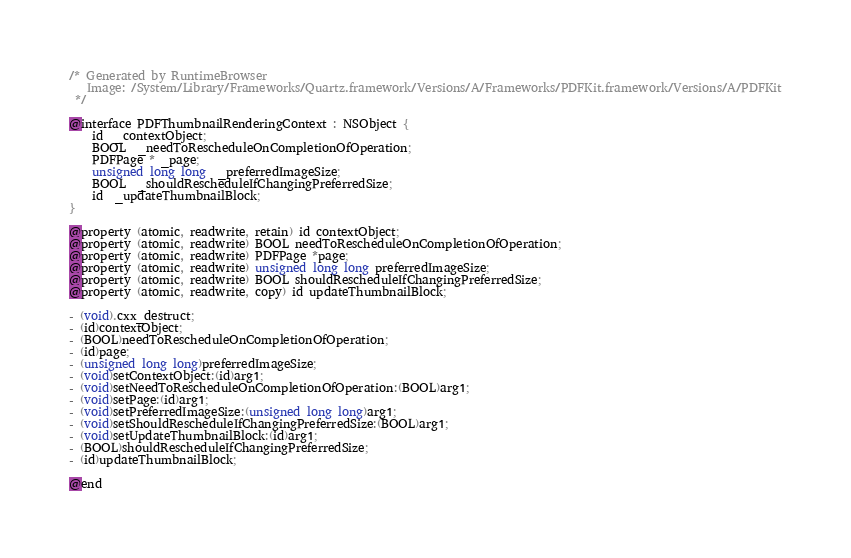Convert code to text. <code><loc_0><loc_0><loc_500><loc_500><_C_>/* Generated by RuntimeBrowser
   Image: /System/Library/Frameworks/Quartz.framework/Versions/A/Frameworks/PDFKit.framework/Versions/A/PDFKit
 */

@interface PDFThumbnailRenderingContext : NSObject {
    id  _contextObject;
    BOOL  _needToRescheduleOnCompletionOfOperation;
    PDFPage * _page;
    unsigned long long  _preferredImageSize;
    BOOL  _shouldRescheduleIfChangingPreferredSize;
    id  _updateThumbnailBlock;
}

@property (atomic, readwrite, retain) id contextObject;
@property (atomic, readwrite) BOOL needToRescheduleOnCompletionOfOperation;
@property (atomic, readwrite) PDFPage *page;
@property (atomic, readwrite) unsigned long long preferredImageSize;
@property (atomic, readwrite) BOOL shouldRescheduleIfChangingPreferredSize;
@property (atomic, readwrite, copy) id updateThumbnailBlock;

- (void).cxx_destruct;
- (id)contextObject;
- (BOOL)needToRescheduleOnCompletionOfOperation;
- (id)page;
- (unsigned long long)preferredImageSize;
- (void)setContextObject:(id)arg1;
- (void)setNeedToRescheduleOnCompletionOfOperation:(BOOL)arg1;
- (void)setPage:(id)arg1;
- (void)setPreferredImageSize:(unsigned long long)arg1;
- (void)setShouldRescheduleIfChangingPreferredSize:(BOOL)arg1;
- (void)setUpdateThumbnailBlock:(id)arg1;
- (BOOL)shouldRescheduleIfChangingPreferredSize;
- (id)updateThumbnailBlock;

@end
</code> 